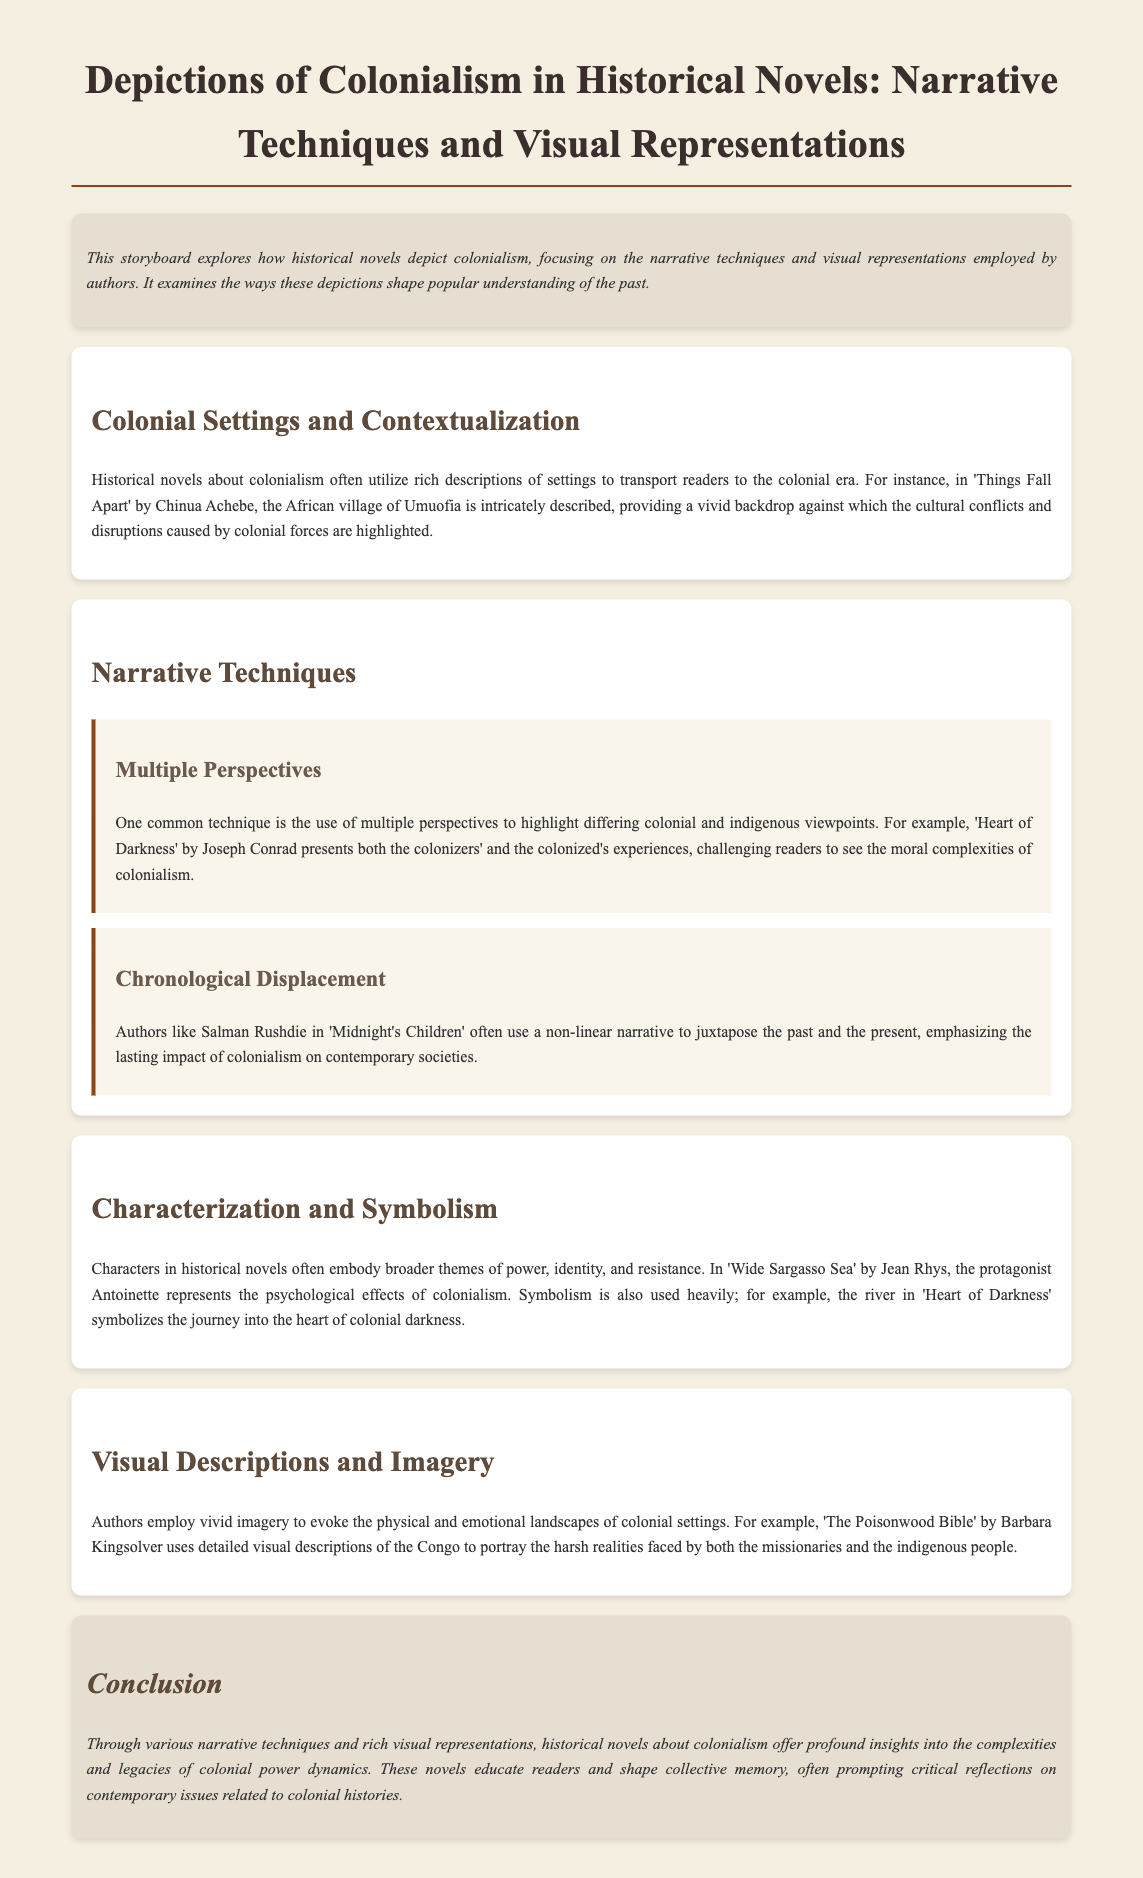What is the title of the storyboard? The title is stated in the main heading of the document.
Answer: Depictions of Colonialism in Historical Novels: Narrative Techniques and Visual Representations Who is the author of 'Things Fall Apart'? The author is mentioned in the context of the novel discussed.
Answer: Chinua Achebe What narrative technique is highlighted in 'Heart of Darkness'? The technique used in the novel is specified in the section on narrative techniques.
Answer: Multiple perspectives Which novel uses a non-linear narrative? The specific example of a novel with this technique is mentioned in the document.
Answer: Midnight's Children What symbol is used in 'Heart of Darkness'? The symbolism mentioned relates to the journey described in the novel.
Answer: The river Which author wrote 'The Poisonwood Bible'? The name of the author associated with the given novel is provided in the text.
Answer: Barbara Kingsolver What theme does Antoinette represent in 'Wide Sargasso Sea'? The theme is described in relation to the protagonist's characterization.
Answer: Psychological effects of colonialism What type of insights do historical novels provide according to the conclusion? The insights described in the conclusion summarize the overall impact of these novels.
Answer: Profound insights on colonial power dynamics 